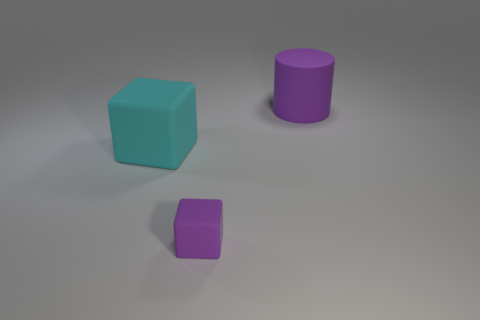Add 1 tiny purple rubber blocks. How many objects exist? 4 Subtract all gray cylinders. How many cyan cubes are left? 1 Subtract all blocks. How many objects are left? 1 Subtract all purple cubes. Subtract all cyan cylinders. How many cubes are left? 1 Subtract all red metallic balls. Subtract all matte blocks. How many objects are left? 1 Add 3 purple objects. How many purple objects are left? 5 Add 1 tiny purple matte things. How many tiny purple matte things exist? 2 Subtract 0 red balls. How many objects are left? 3 